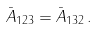<formula> <loc_0><loc_0><loc_500><loc_500>\bar { A } _ { 1 2 3 } = \bar { A } _ { 1 3 2 } \, .</formula> 